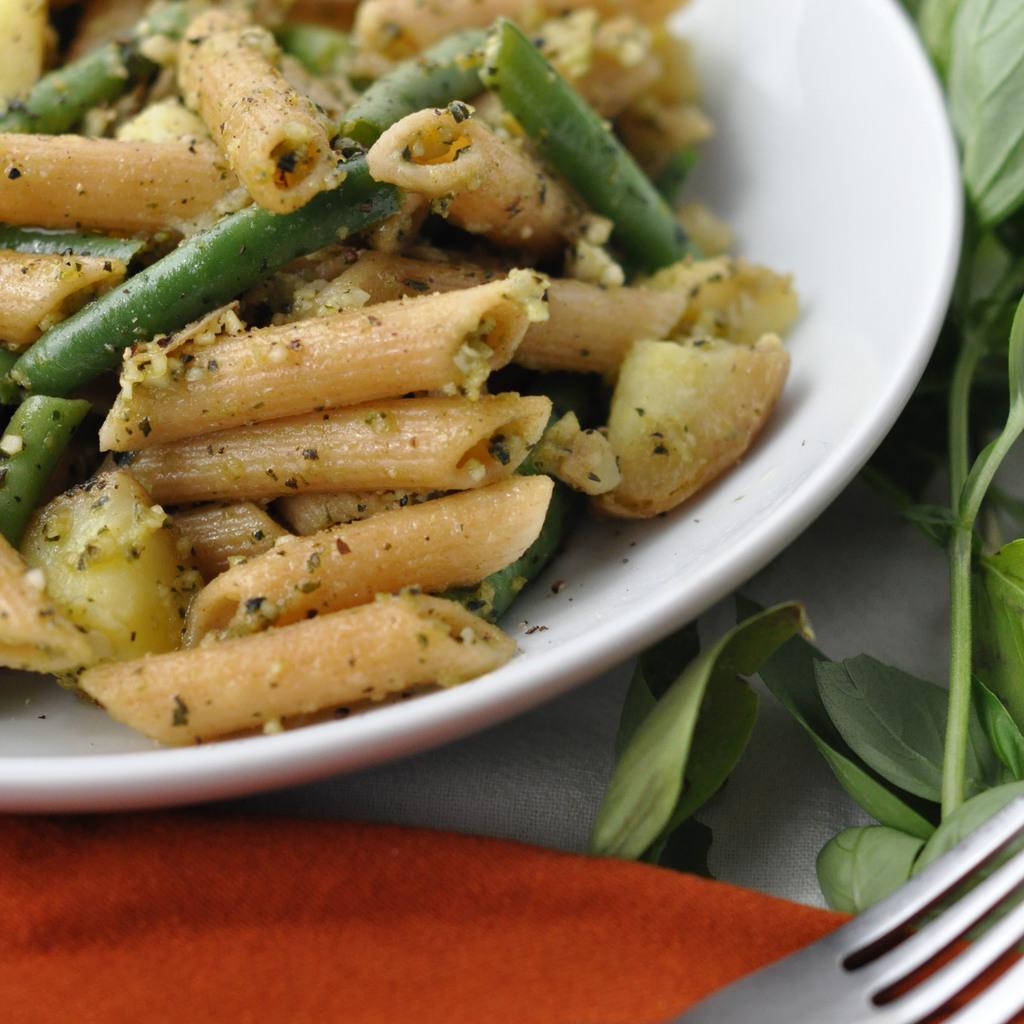Please provide a concise description of this image. In the center of this picture we can see a white color platter containing pasta and the beans and some food items and we can see a napkin, fork, green leaves and the stems. 